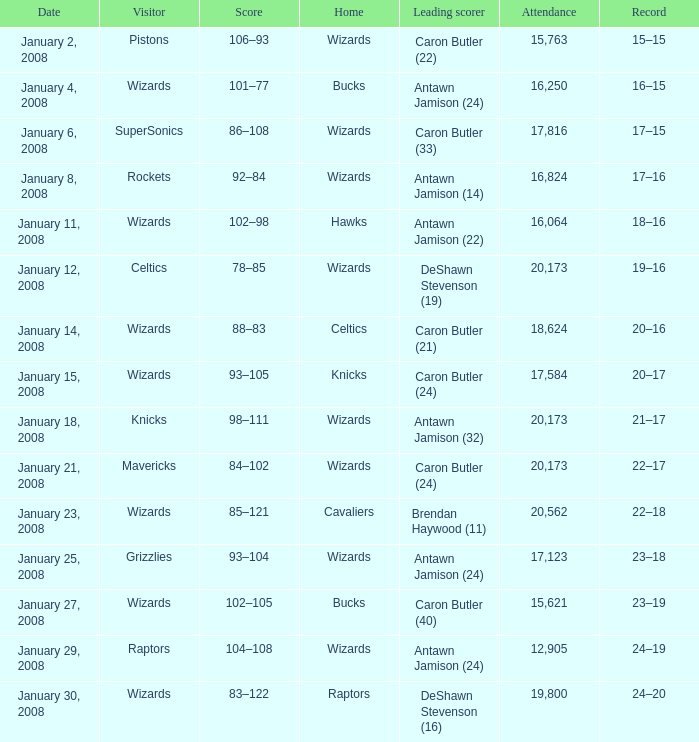What is the record when the leading scorer is Antawn Jamison (14)? 17–16. 